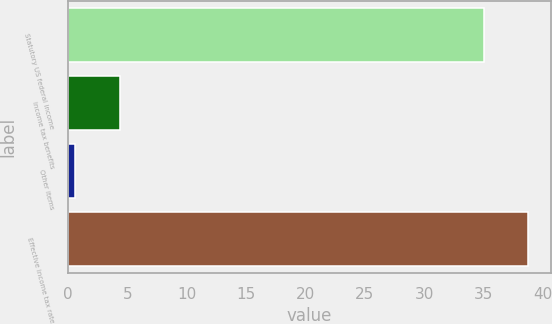Convert chart to OTSL. <chart><loc_0><loc_0><loc_500><loc_500><bar_chart><fcel>Statutory US federal income<fcel>income tax benefits<fcel>Other items<fcel>Effective income tax rate<nl><fcel>35<fcel>4.37<fcel>0.6<fcel>38.77<nl></chart> 